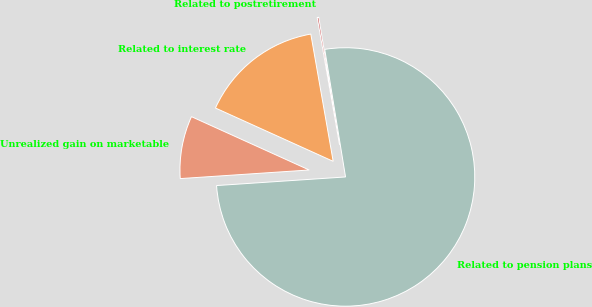Convert chart. <chart><loc_0><loc_0><loc_500><loc_500><pie_chart><fcel>Unrealized gain on marketable<fcel>Related to pension plans<fcel>Related to postretirement<fcel>Related to interest rate<nl><fcel>7.83%<fcel>76.51%<fcel>0.2%<fcel>15.46%<nl></chart> 